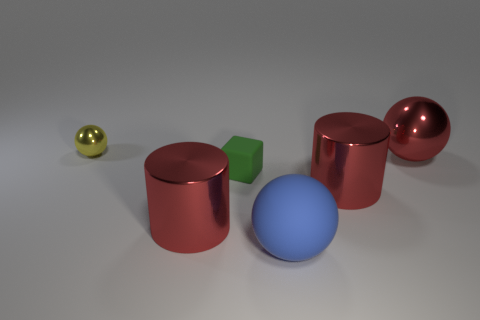Subtract all small spheres. How many spheres are left? 2 Add 4 tiny rubber things. How many objects exist? 10 Subtract all cylinders. How many objects are left? 4 Subtract all spheres. Subtract all large red things. How many objects are left? 0 Add 5 large blue matte spheres. How many large blue matte spheres are left? 6 Add 6 metal spheres. How many metal spheres exist? 8 Subtract 0 gray blocks. How many objects are left? 6 